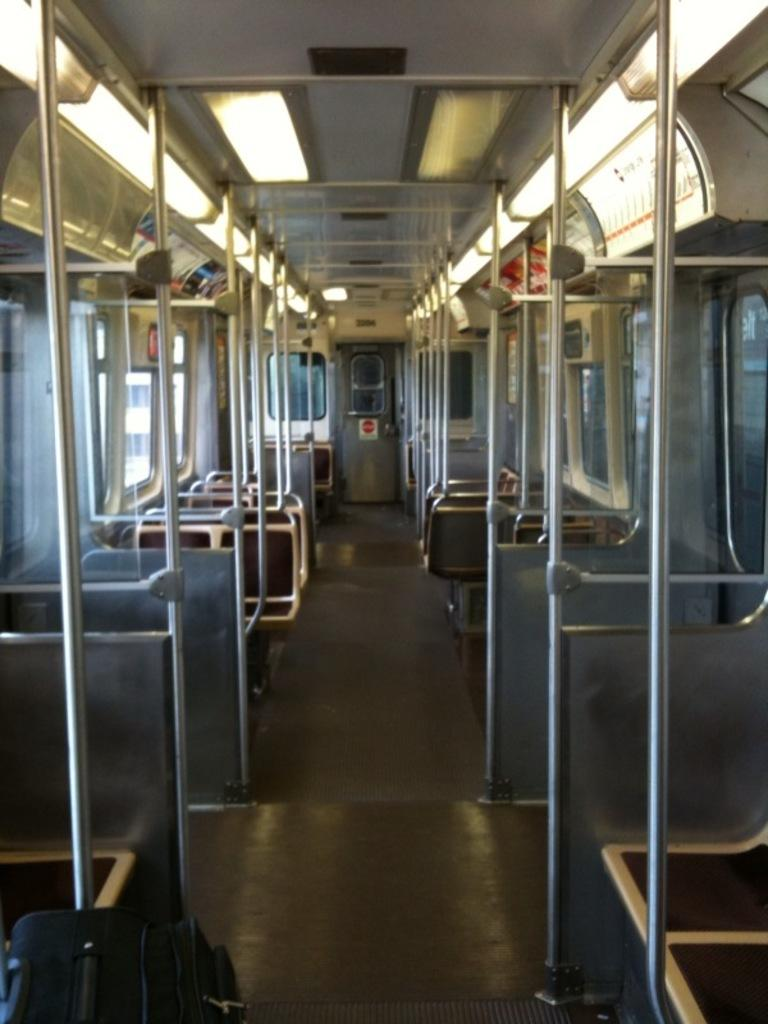What can you describe the seating arrangement in the image? There are many seats on both the left and right sides of the image. What other features can be seen in the image besides the seats? There are many windows visible in the image. Is there any entrance or exit visible in the image? Yes, there is a door visible in the background of the image. How many kittens can be seen shaking hands in the image? There are no kittens or handshakes present in the image. 